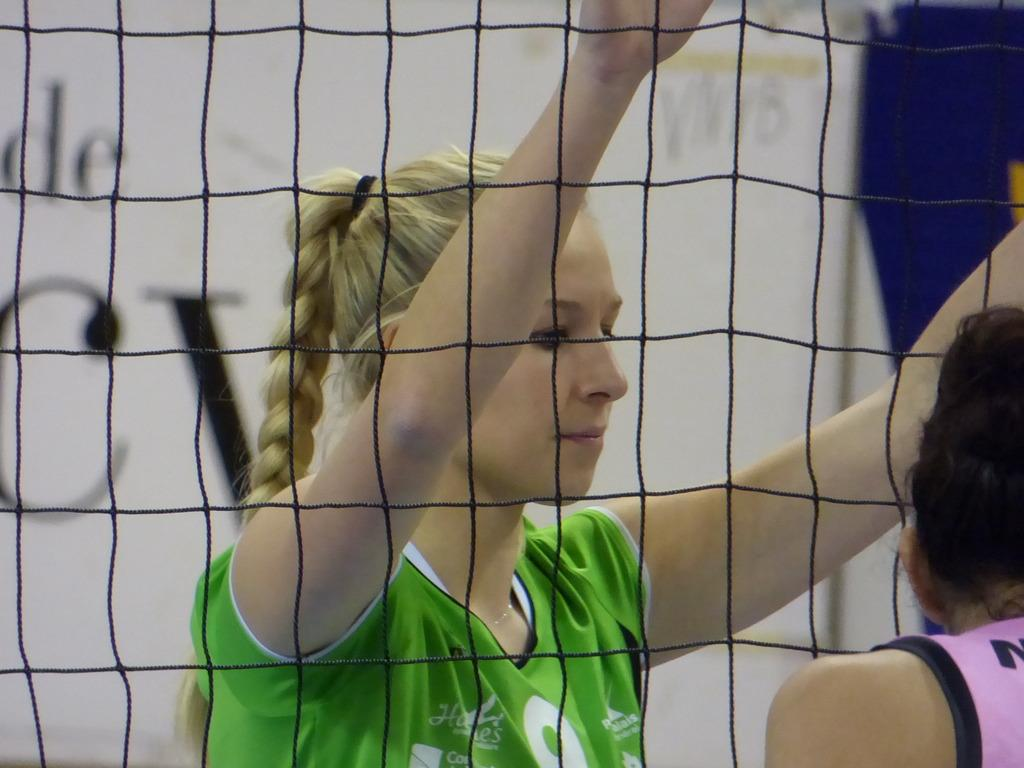Who is the main subject in the front of the image? There is a person in the front of the image. What is the material of the mesh in the image? The mesh is visible in the image. Can you describe the woman visible through the mesh? A woman is visible through the mesh. What additional element can be seen in the image? There is a banner in the image. What type of car is parked behind the mesh in the image? There is no car visible in the image; it only features a person, mesh, woman, and banner. 